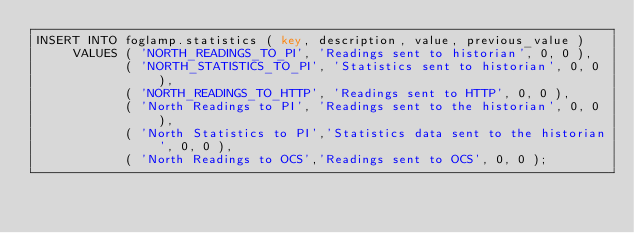Convert code to text. <code><loc_0><loc_0><loc_500><loc_500><_SQL_>INSERT INTO foglamp.statistics ( key, description, value, previous_value )
     VALUES ( 'NORTH_READINGS_TO_PI', 'Readings sent to historian', 0, 0 ),
            ( 'NORTH_STATISTICS_TO_PI', 'Statistics sent to historian', 0, 0 ),
            ( 'NORTH_READINGS_TO_HTTP', 'Readings sent to HTTP', 0, 0 ),
            ( 'North Readings to PI', 'Readings sent to the historian', 0, 0 ),
            ( 'North Statistics to PI','Statistics data sent to the historian', 0, 0 ),
            ( 'North Readings to OCS','Readings sent to OCS', 0, 0 );
</code> 